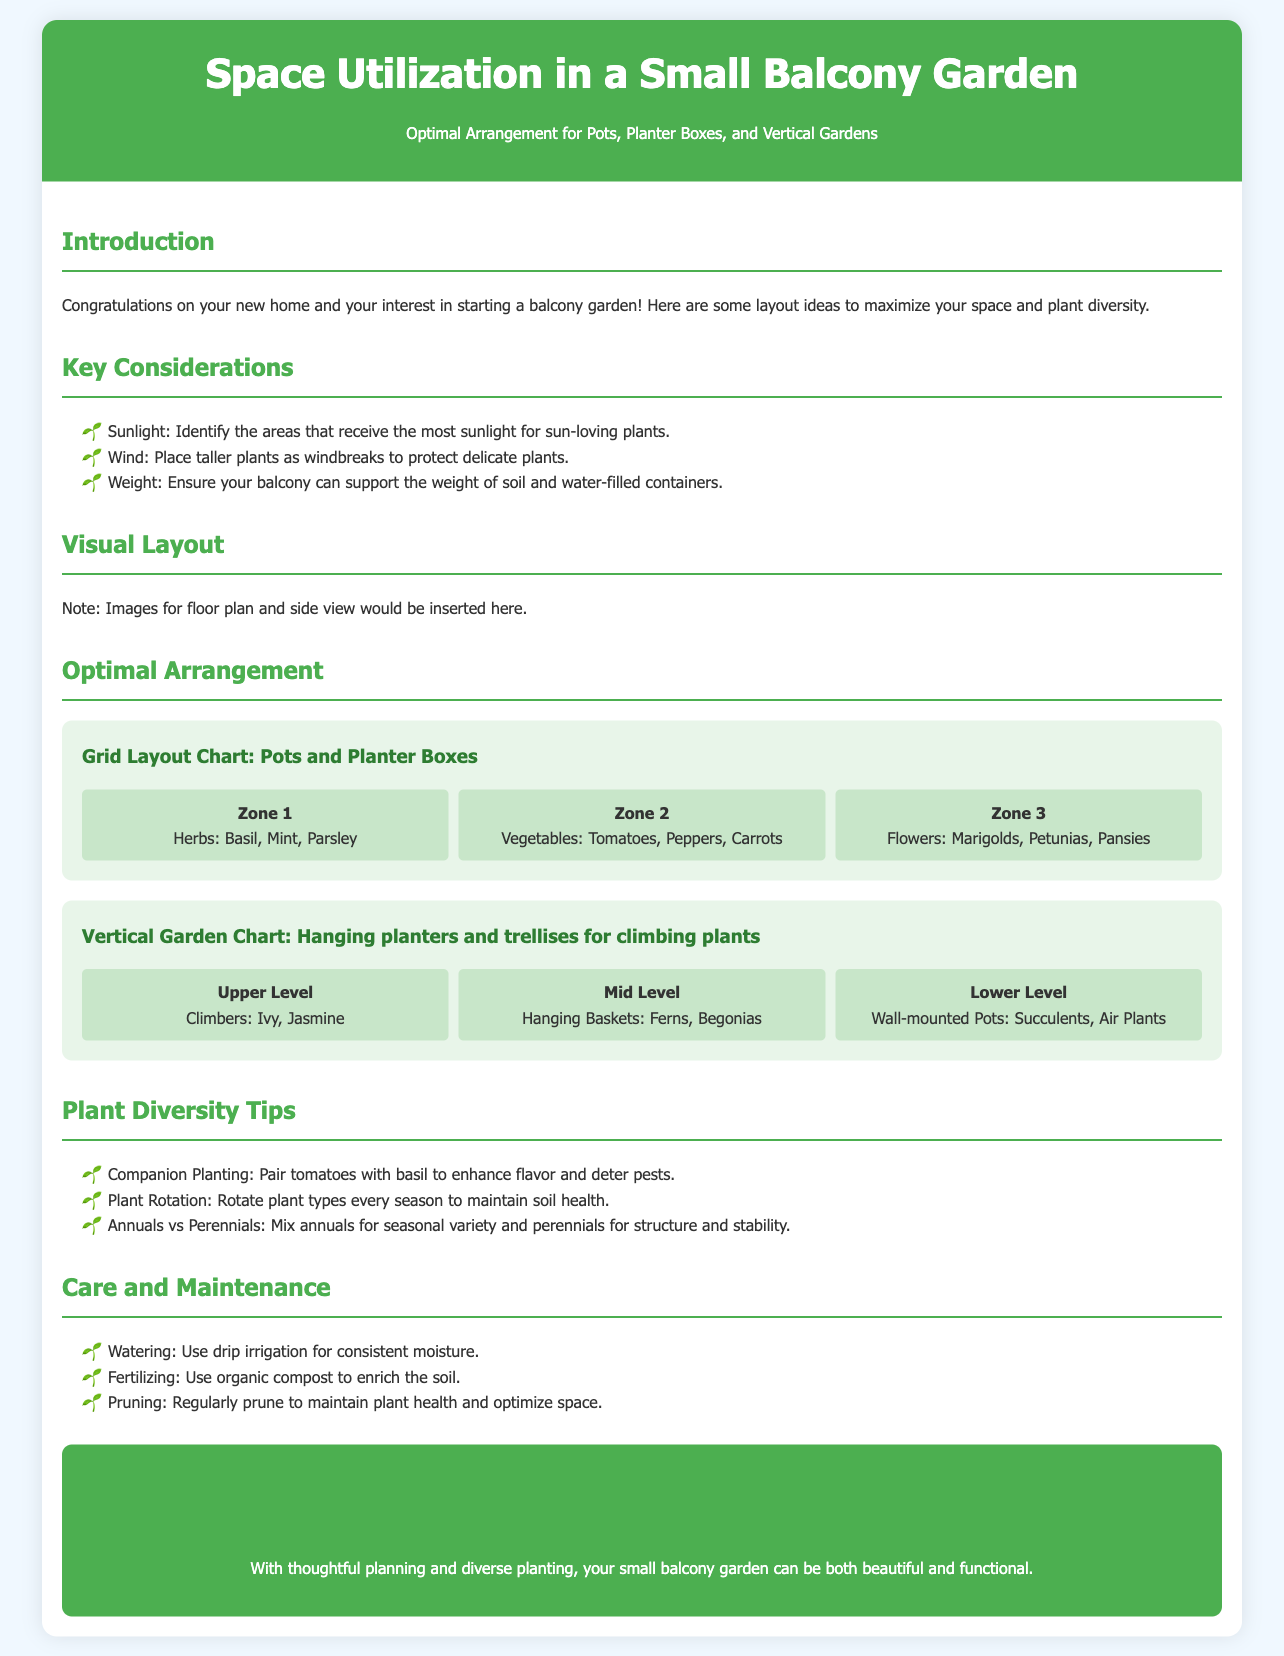what are the three types of plants in Zone 1? Zone 1 includes herbs such as Basil, Mint, and Parsley.
Answer: Basil, Mint, Parsley which vegetables are listed in Zone 2? Zone 2 features vegetables including Tomatoes, Peppers, and Carrots.
Answer: Tomatoes, Peppers, Carrots what type of plants are recommended for the Upper Level of the vertical garden? The Upper Level suggests using climbers like Ivy and Jasmine.
Answer: Ivy, Jasmine how many zones are shown in the Grid Layout Chart? The document displays three zones in the Grid Layout Chart for optimal arrangement.
Answer: 3 what is the purpose of using drip irrigation according to the Care and Maintenance section? Drip irrigation is recommended for consistent moisture for the plants.
Answer: consistent moisture what is a benefit of companion planting mentioned? It enhances flavor and deters pests when pairing tomatoes with basil.
Answer: enhances flavor and deters pests what color is used for the background of the document? The background color of the document is a light blue tone, identified as #f0f8ff.
Answer: light blue what should be mixed with annuals for seasonal variety? The document suggests mixing perennials for structure and stability along with annuals.
Answer: perennials what should be used to enrich the soil? Organic compost is recommended for soil enrichment.
Answer: organic compost 